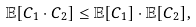Convert formula to latex. <formula><loc_0><loc_0><loc_500><loc_500>\mathbb { E } [ C _ { 1 } \cdot C _ { 2 } ] \leq \mathbb { E } [ C _ { 1 } ] \cdot \mathbb { E } [ C _ { 2 } ] ,</formula> 